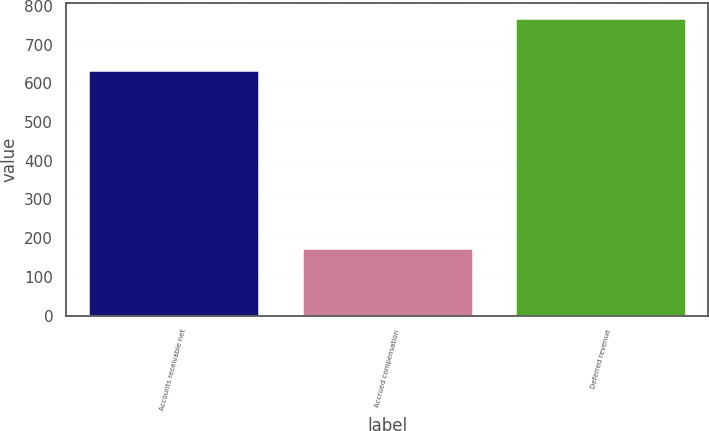<chart> <loc_0><loc_0><loc_500><loc_500><bar_chart><fcel>Accounts receivable net<fcel>Accrued compensation<fcel>Deferred revenue<nl><fcel>635.6<fcel>174<fcel>770.2<nl></chart> 